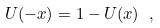<formula> <loc_0><loc_0><loc_500><loc_500>U ( - x ) = 1 - U ( x ) \ ,</formula> 